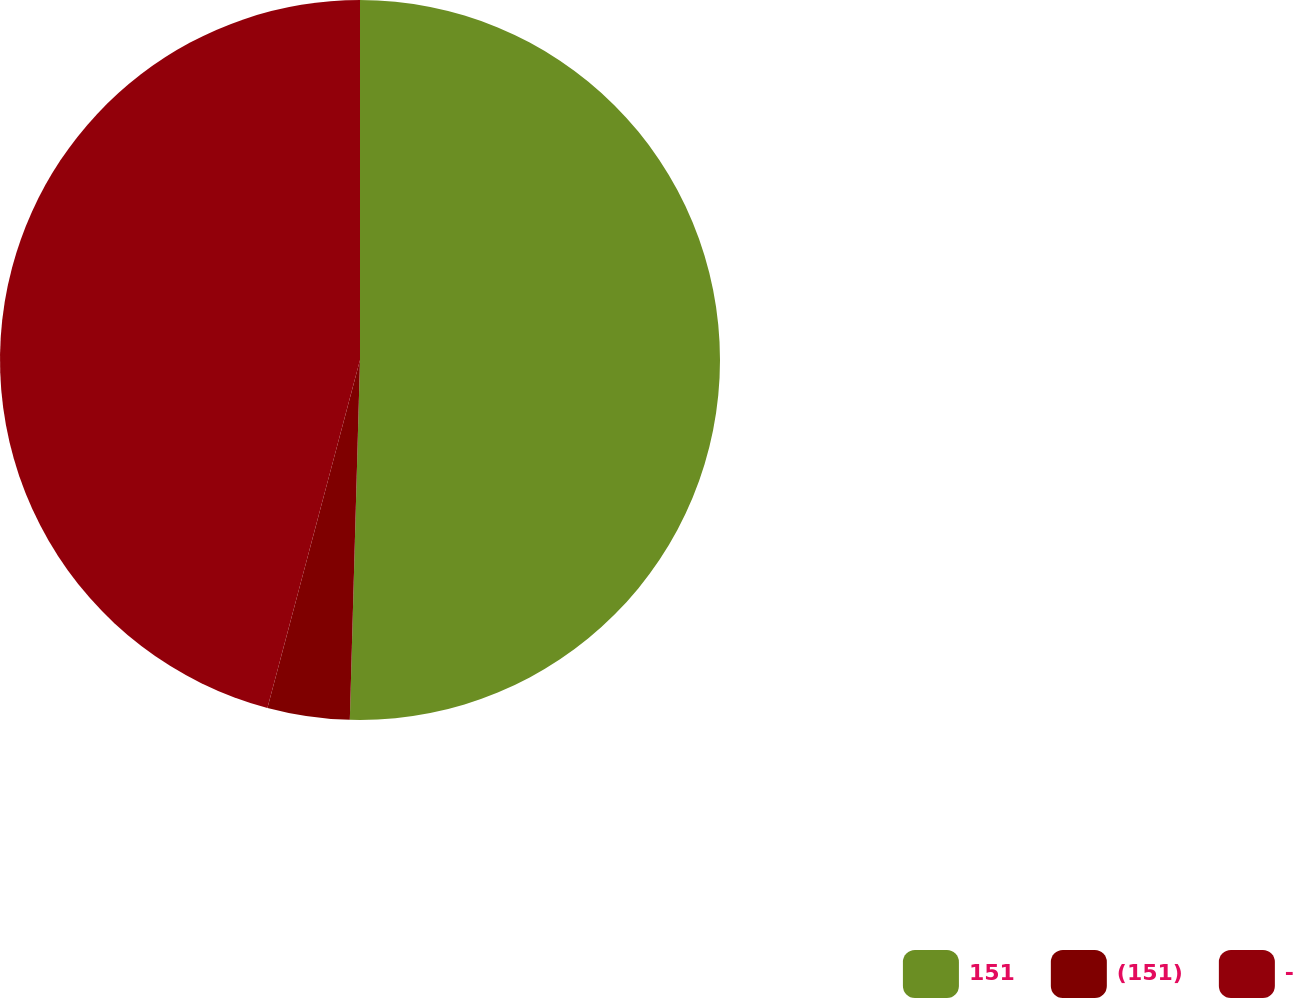Convert chart to OTSL. <chart><loc_0><loc_0><loc_500><loc_500><pie_chart><fcel>151<fcel>(151)<fcel>-<nl><fcel>50.45%<fcel>3.69%<fcel>45.86%<nl></chart> 